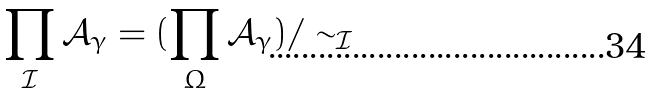Convert formula to latex. <formula><loc_0><loc_0><loc_500><loc_500>\prod _ { \mathcal { I } } \mathcal { A } _ { \gamma } = ( \prod _ { \Omega } \mathcal { A } _ { \gamma } ) / \sim _ { \mathcal { I } }</formula> 